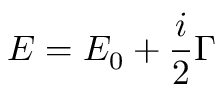<formula> <loc_0><loc_0><loc_500><loc_500>E = E _ { 0 } + \frac { i } { 2 } \Gamma</formula> 